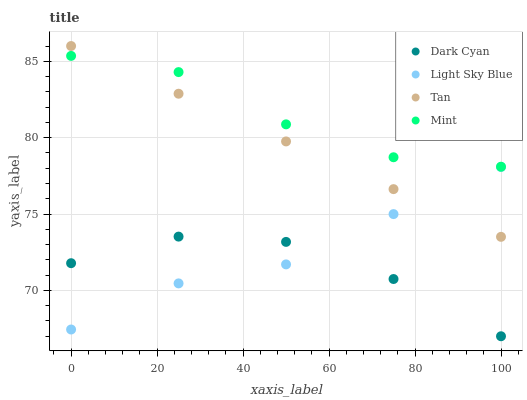Does Dark Cyan have the minimum area under the curve?
Answer yes or no. Yes. Does Mint have the maximum area under the curve?
Answer yes or no. Yes. Does Tan have the minimum area under the curve?
Answer yes or no. No. Does Tan have the maximum area under the curve?
Answer yes or no. No. Is Tan the smoothest?
Answer yes or no. Yes. Is Dark Cyan the roughest?
Answer yes or no. Yes. Is Light Sky Blue the smoothest?
Answer yes or no. No. Is Light Sky Blue the roughest?
Answer yes or no. No. Does Dark Cyan have the lowest value?
Answer yes or no. Yes. Does Tan have the lowest value?
Answer yes or no. No. Does Tan have the highest value?
Answer yes or no. Yes. Does Light Sky Blue have the highest value?
Answer yes or no. No. Is Dark Cyan less than Tan?
Answer yes or no. Yes. Is Mint greater than Light Sky Blue?
Answer yes or no. Yes. Does Light Sky Blue intersect Dark Cyan?
Answer yes or no. Yes. Is Light Sky Blue less than Dark Cyan?
Answer yes or no. No. Is Light Sky Blue greater than Dark Cyan?
Answer yes or no. No. Does Dark Cyan intersect Tan?
Answer yes or no. No. 